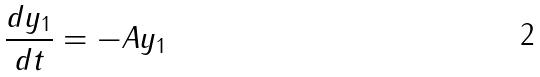Convert formula to latex. <formula><loc_0><loc_0><loc_500><loc_500>\frac { d y _ { 1 } } { d t } = - A y _ { 1 }</formula> 